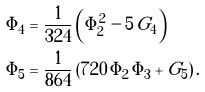<formula> <loc_0><loc_0><loc_500><loc_500>\Phi _ { 4 } = & \ \frac { 1 } { 3 2 4 } \left ( \Phi _ { 2 } ^ { 2 } - 5 \, G _ { 4 } \right ) \\ \Phi _ { 5 } = & \ \frac { 1 } { 8 6 4 } \left ( 7 2 0 \, \Phi _ { 2 } \, \Phi _ { 3 } + G _ { 5 } \right ) .</formula> 